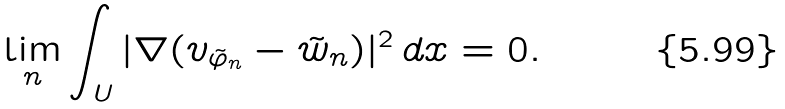Convert formula to latex. <formula><loc_0><loc_0><loc_500><loc_500>\lim _ { n } \int _ { U } | \nabla ( v _ { \tilde { \varphi } _ { n } } - \tilde { w } _ { n } ) | ^ { 2 } \, d x = 0 .</formula> 